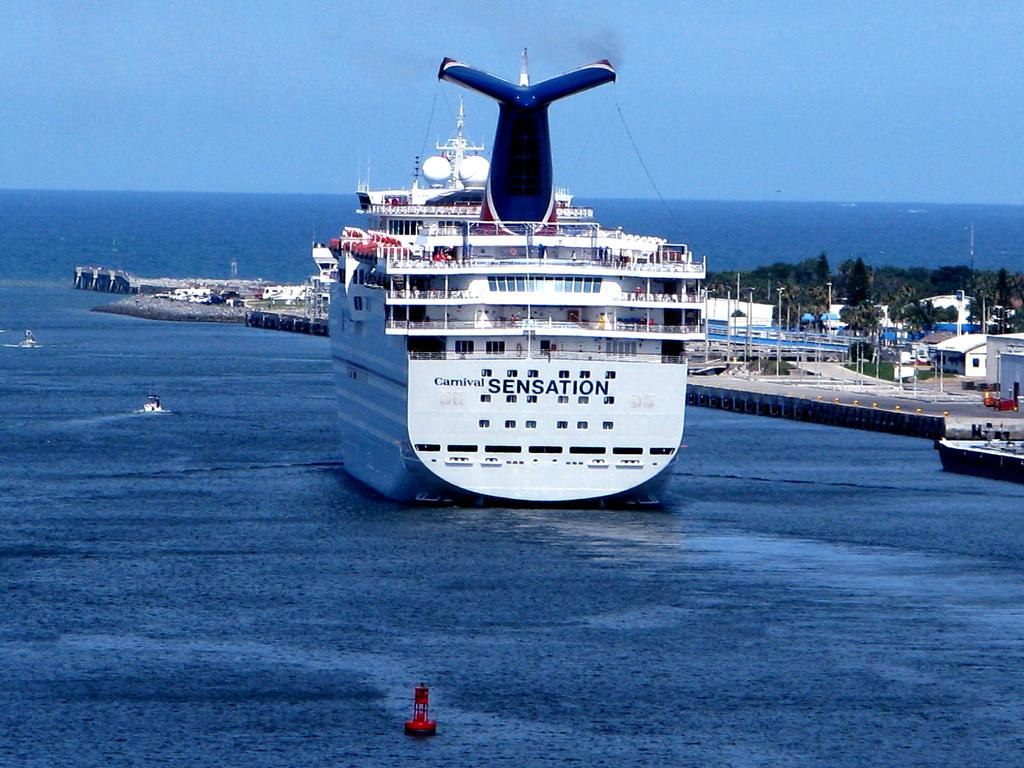What is the main subject in the image? There is a big ship in the image. What other objects can be seen in the image? There are small boats in the image. Where are the boats located? The boats are on the water. What type of location is depicted in the image? There is a harbor in the image. What structures can be seen in the harbor? There are buildings and trees in the harbor. Can you tell me how many points the woman scored in the image? There is no woman or any reference to scoring points in the image. 